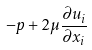<formula> <loc_0><loc_0><loc_500><loc_500>- p + 2 \mu \frac { \partial u _ { i } } { \partial x _ { i } }</formula> 